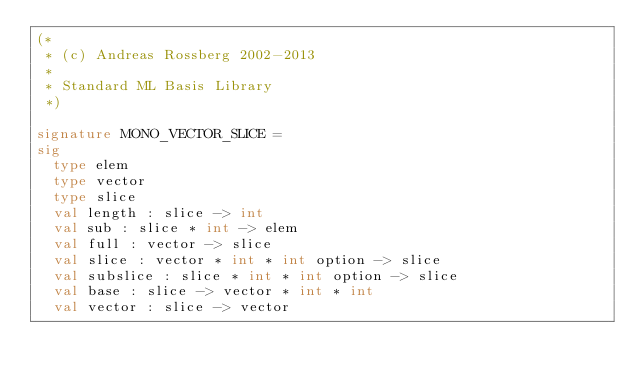<code> <loc_0><loc_0><loc_500><loc_500><_SML_>(*
 * (c) Andreas Rossberg 2002-2013
 *
 * Standard ML Basis Library
 *)

signature MONO_VECTOR_SLICE =
sig
  type elem
  type vector
  type slice
  val length : slice -> int
  val sub : slice * int -> elem
  val full : vector -> slice
  val slice : vector * int * int option -> slice
  val subslice : slice * int * int option -> slice
  val base : slice -> vector * int * int
  val vector : slice -> vector</code> 